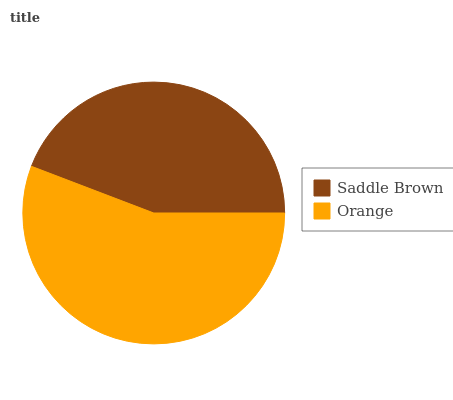Is Saddle Brown the minimum?
Answer yes or no. Yes. Is Orange the maximum?
Answer yes or no. Yes. Is Orange the minimum?
Answer yes or no. No. Is Orange greater than Saddle Brown?
Answer yes or no. Yes. Is Saddle Brown less than Orange?
Answer yes or no. Yes. Is Saddle Brown greater than Orange?
Answer yes or no. No. Is Orange less than Saddle Brown?
Answer yes or no. No. Is Orange the high median?
Answer yes or no. Yes. Is Saddle Brown the low median?
Answer yes or no. Yes. Is Saddle Brown the high median?
Answer yes or no. No. Is Orange the low median?
Answer yes or no. No. 